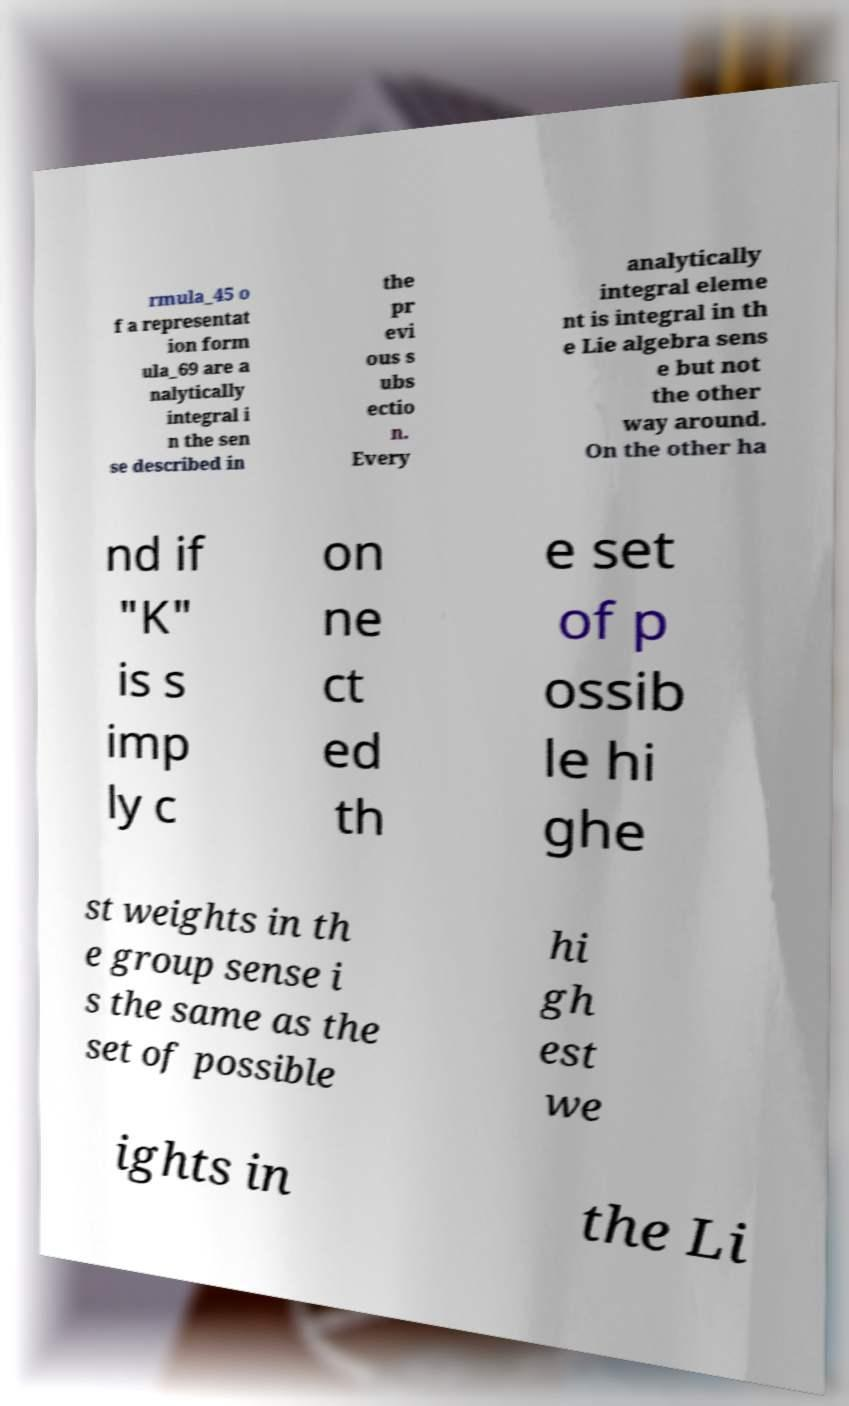Please read and relay the text visible in this image. What does it say? rmula_45 o f a representat ion form ula_69 are a nalytically integral i n the sen se described in the pr evi ous s ubs ectio n. Every analytically integral eleme nt is integral in th e Lie algebra sens e but not the other way around. On the other ha nd if "K" is s imp ly c on ne ct ed th e set of p ossib le hi ghe st weights in th e group sense i s the same as the set of possible hi gh est we ights in the Li 